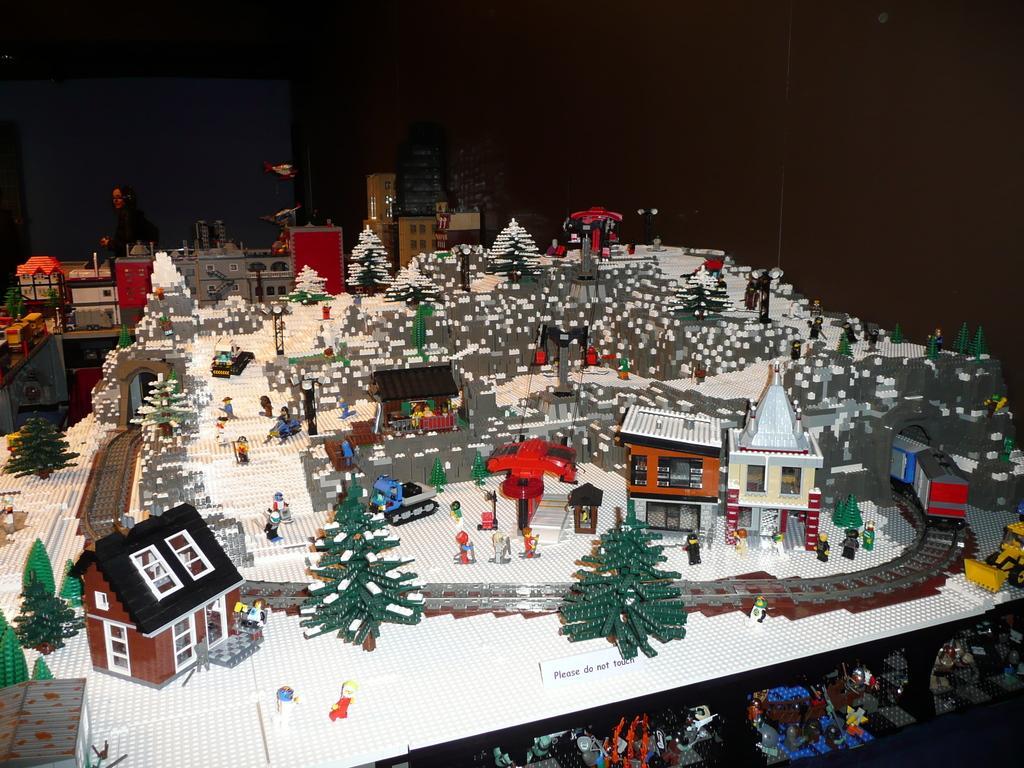In one or two sentences, can you explain what this image depicts? In this image there are houses and trees. There are Xmas trees. There is a railway track. There is a train. On the right side, there is a machine. There are mannequins. There are buildings in the background. 